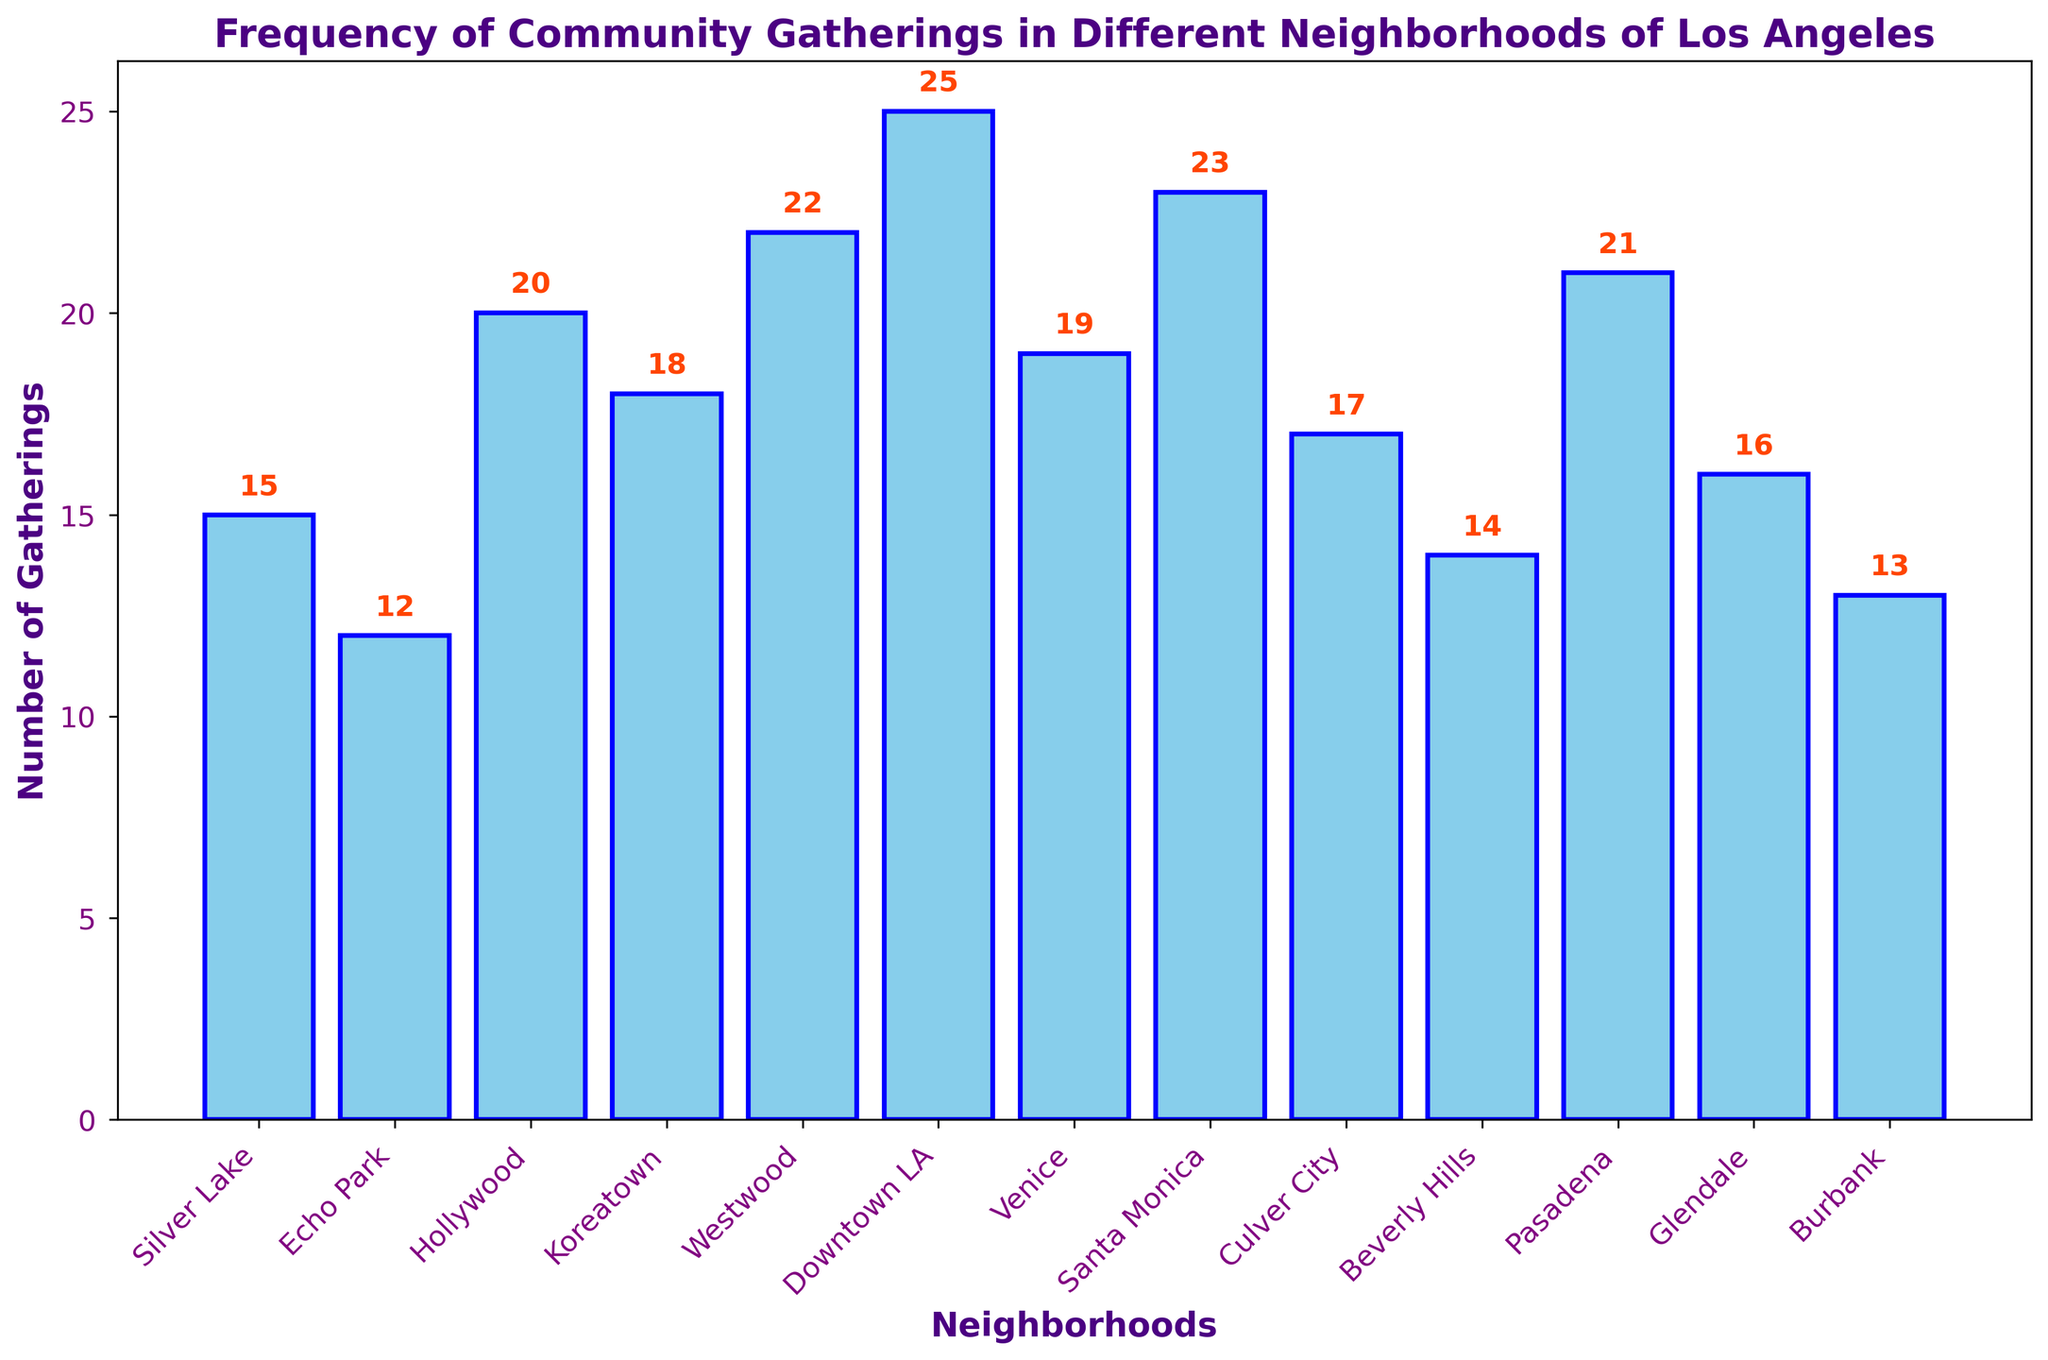What’s the total number of community gatherings in Silver Lake, Hollywood, and Downtown LA? First, identify the number of gatherings in Silver Lake (15), Hollywood (20), and Downtown LA (25). Then, sum these values: 15 + 20 + 25 = 60.
Answer: 60 Which neighborhood has the highest frequency of community gatherings, and how many gatherings does it have? The bar representing the highest frequency is for Downtown LA, which has 25 gatherings.
Answer: Downtown LA, 25 Is the number of gatherings in Pasadena higher, lower, or equal to that in Glendale? Compare the height of the bars for Pasadena (21) and Glendale (16). Since 21 > 16, Pasadena has a higher number of gatherings.
Answer: Higher What is the difference in the number of gatherings between Westwood and Beverly Hills? Identify the values for Westwood (22) and Beverly Hills (14), then subtract the smaller from the larger: 22 - 14 = 8.
Answer: 8 Are there more community gatherings in Echo Park or Burbank, and by how many? Echo Park has 12 gatherings, and Burbank has 13. Calculate the difference: 13 - 12 = 1.
Answer: Burbank, 1 What is the average number of community gatherings in Koreatown, Venice, and Santa Monica? Gather the values for Koreatown (18), Venice (19), and Santa Monica (23). Sum these values and divide by the number of neighborhoods: (18 + 19 + 23) / 3 = 60 / 3 = 20.
Answer: 20 Which neighborhood has fewer gatherings: Culver City or Beverly Hills? Compare the number of gatherings in Culver City (17) and Beverly Hills (14), and determine that Beverly Hills has fewer.
Answer: Beverly Hills How many neighborhoods have more than 20 community gatherings? Count the bars where the height represents more than 20 gatherings: Westwood (22), Downtown LA (25), Santa Monica (23), Pasadena (21). There are 4 such neighborhoods.
Answer: 4 What’s the combined number of gatherings for neighborhoods with fewer than 15 gatherings? Identify the neighborhoods with fewer than 15 gatherings: Echo Park (12), Beverly Hills (14), and Burbank (13). Sum these values: 12 + 14 + 13 = 39.
Answer: 39 How many unique labels are used for the x-axis, and what does this represent? Count the labeled bars on the x-axis, which corresponds to the number of unique neighborhoods. There are 13 neighborhoods labeled.
Answer: 13 